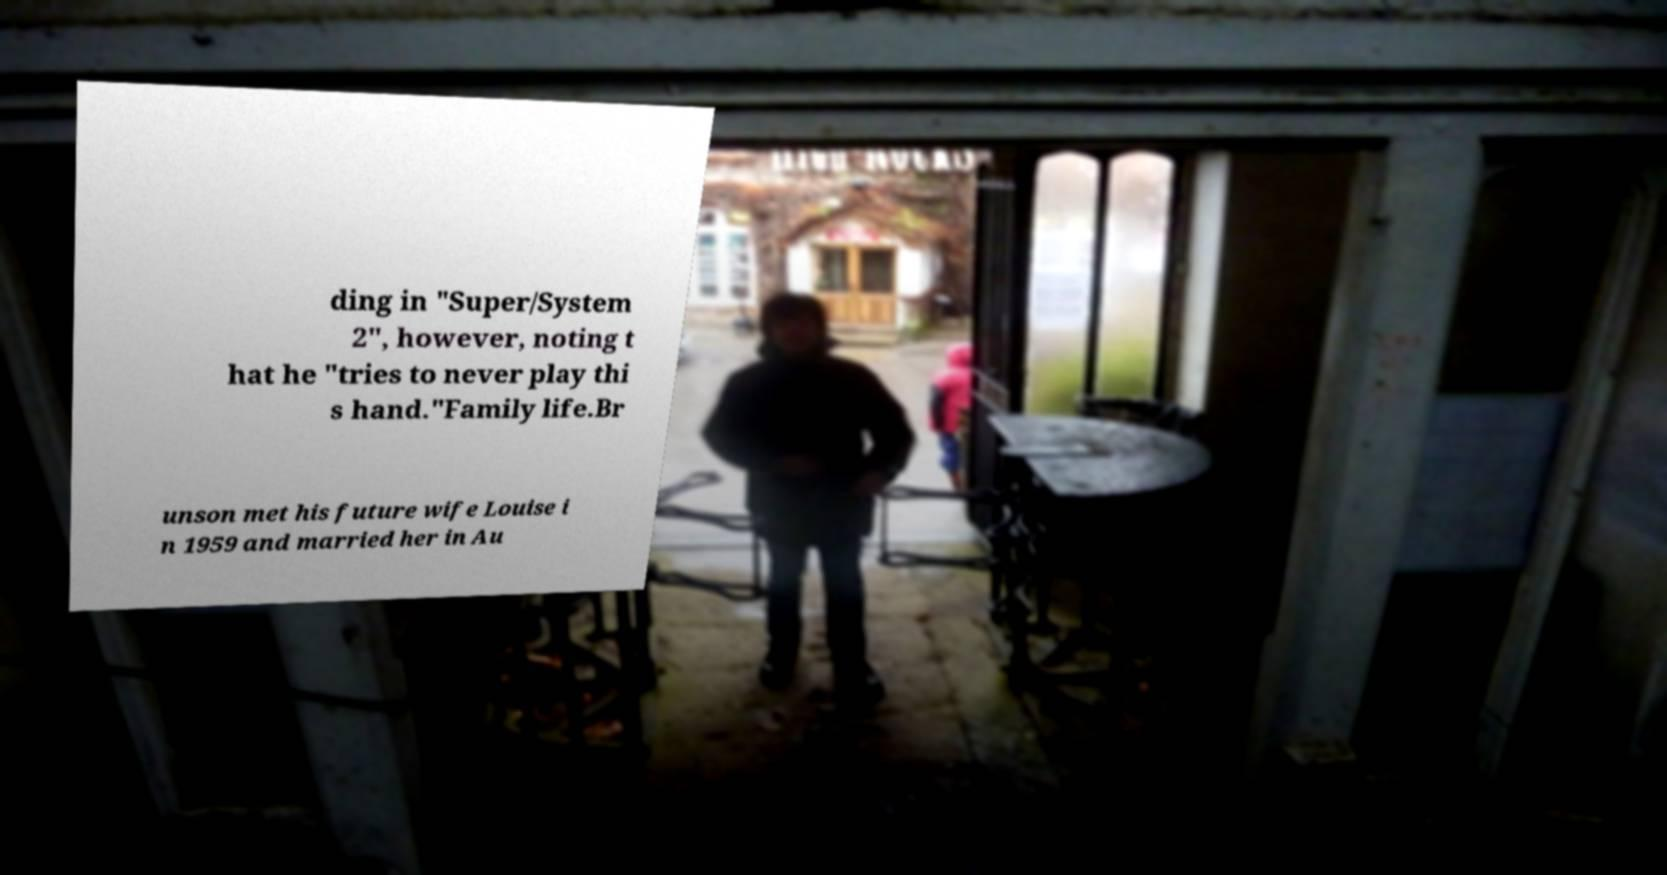Can you read and provide the text displayed in the image?This photo seems to have some interesting text. Can you extract and type it out for me? ding in "Super/System 2", however, noting t hat he "tries to never play thi s hand."Family life.Br unson met his future wife Louise i n 1959 and married her in Au 